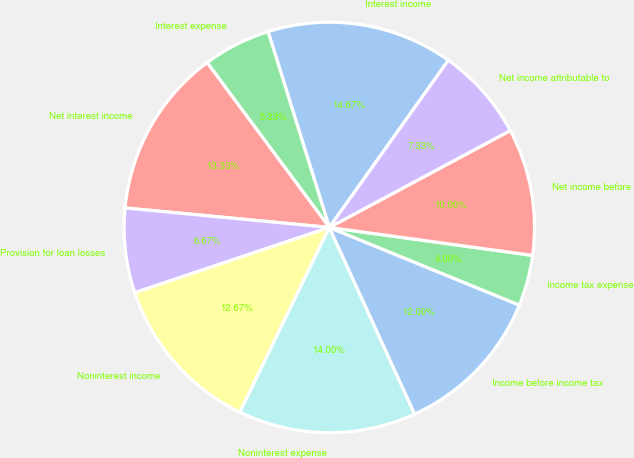<chart> <loc_0><loc_0><loc_500><loc_500><pie_chart><fcel>Interest income<fcel>Interest expense<fcel>Net interest income<fcel>Provision for loan losses<fcel>Noninterest income<fcel>Noninterest expense<fcel>Income before income tax<fcel>Income tax expense<fcel>Net income before<fcel>Net income attributable to<nl><fcel>14.67%<fcel>5.33%<fcel>13.33%<fcel>6.67%<fcel>12.67%<fcel>14.0%<fcel>12.0%<fcel>4.0%<fcel>10.0%<fcel>7.33%<nl></chart> 